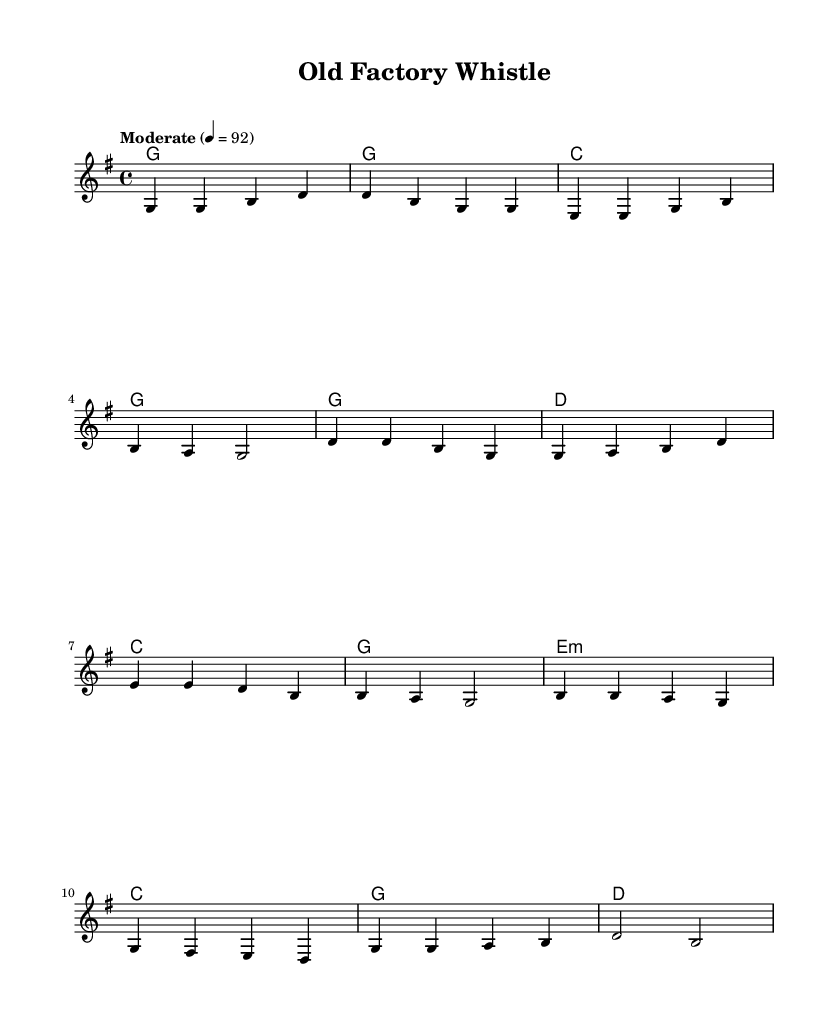What is the key signature of this music? The key signature is G major, indicated by one sharp (F#).
Answer: G major What is the time signature of this piece? The time signature is 4/4, meaning there are four beats per measure with a quarter note getting one beat.
Answer: 4/4 What tempo marking is indicated for this piece? The tempo marking is "Moderate," with a metronome marking of 92 beats per minute.
Answer: Moderate Which section of the song has the lyrics "Oh, those simple times we knew"? This line appears in the chorus section, defined by the corresponding lyric mode in the sheet music.
Answer: Chorus What is the overall mood conveyed in the title of the song? The title "Old Factory Whistle" suggests a nostalgic and reflective mood about past experiences in a factory setting.
Answer: Nostalgic Which chord is used in the bridge? The bridge uses the E minor chord, specifically indicated in the chord mode section.
Answer: E minor 